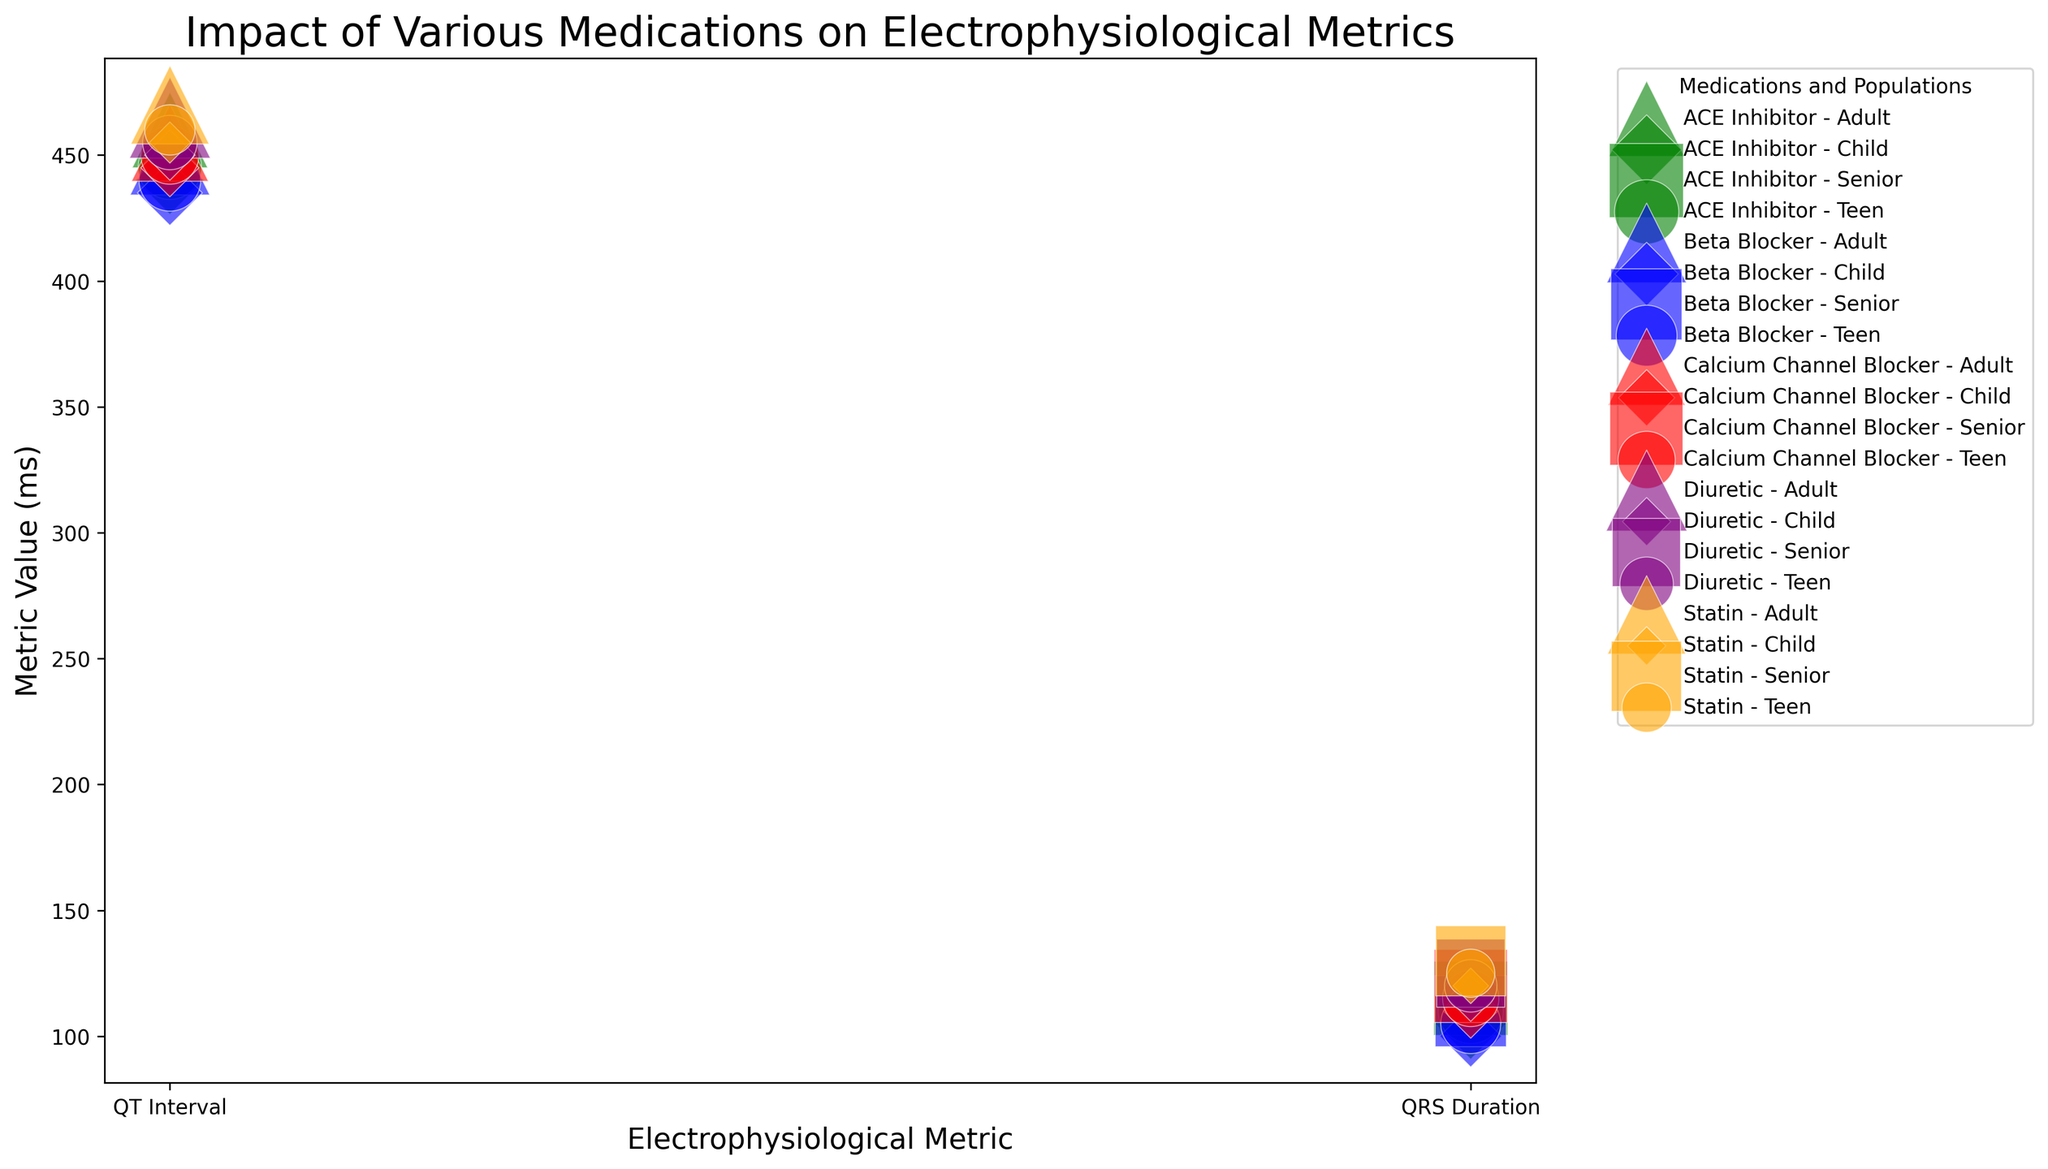What is the average QT Interval value for adults taking the medications listed? To find the average QT Interval value for adults, we sum the QT Interval values for all adult groups and divide by the number of groups. (450 + 460 + 455 + 465 + 470) / 5 = 2300 / 5 = 460 ms
Answer: 460 ms Which medication leads to the shortest QT Interval in children? By comparing all the QT Interval values for children, we can see Beta Blocker has the shortest QT Interval at 435 ms.
Answer: Beta Blocker How do the Metric Values for QT Interval compare between teens taking Beta Blockers and Statins? Comparing the Metric Values for QT Interval, Beta Blockers have 440 ms and Statins have 460 ms, making Statins 20 ms longer than Beta Blockers.
Answer: Statins are 20 ms longer What is the total number of patients using Calcium Channel Blockers across all populations? Summing the number of patients using Calcium Channel Blockers for all populations: 140 (Adult) + 125 (Senior) + 80 (Teen) + 40 (Child) = 385 patients.
Answer: 385 Which age group has the highest QRS Duration value for ACE Inhibitor, and what is that value? Looking at the QRS Duration values for ACE Inhibitor, the Senior group has the highest value at 115 ms.
Answer: Senior, 115 ms What is the difference in the number of patients between the Adult and Child populations for Diuretics? The number of patients for Diuretics in Adults is 155 and in Children is 30, so the difference is 155 - 30 = 125 patients.
Answer: 125 patients Which medication causes the longest QT Interval value within the Adult population? Comparing the QT Interval values for adults, Statin has the longest interval at 470 ms.
Answer: Statin How does the QRS Duration for Beta Blockers compare between Adults and Teens? The QRS Duration for Beta Blockers is 110 ms for Adults and 105 ms for Teens, with the duration being 5 ms longer for Adults.
Answer: 5 ms longer for Adults Which medication has the most substantial variability in QT Interval values across different age groups? By observing the spread of QT Interval values, Beta Blockers range from 435 ms (Child) to 450 ms (Adult), showing minimal variability compared to others.
Answer: Minimal variability for Beta Blocker What is the average number of patients for each medication in the Senior population? Summing the number of patients for all medications in the Senior group and dividing by the number of medications: (120 + 130 + 125 + 110 + 115) / 5 = 600 / 5 = 120 patients.
Answer: 120 